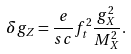Convert formula to latex. <formula><loc_0><loc_0><loc_500><loc_500>\delta { g } _ { Z } = { \frac { e } { s c } } { f } _ { t } ^ { 2 } { \frac { { g } _ { X } ^ { 2 } } { { M } _ { X } ^ { 2 } } } .</formula> 